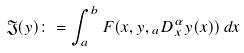<formula> <loc_0><loc_0><loc_500><loc_500>\mathfrak { J } ( y ) \colon = \int _ { a } ^ { b } F ( x , y , { _ { a } D ^ { \alpha } _ { x } } y ( x ) ) \, d x</formula> 